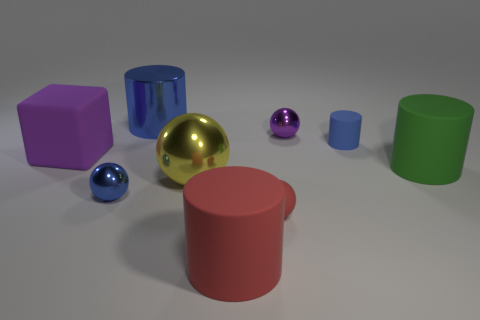Subtract all blue metallic balls. How many balls are left? 3 Subtract all green cylinders. How many cylinders are left? 3 Add 1 tiny purple spheres. How many objects exist? 10 Subtract all cylinders. How many objects are left? 5 Subtract 1 cubes. How many cubes are left? 0 Subtract 0 red blocks. How many objects are left? 9 Subtract all cyan blocks. Subtract all brown cylinders. How many blocks are left? 1 Subtract all green blocks. How many yellow balls are left? 1 Subtract all big purple rubber things. Subtract all yellow metallic balls. How many objects are left? 7 Add 8 red rubber things. How many red rubber things are left? 10 